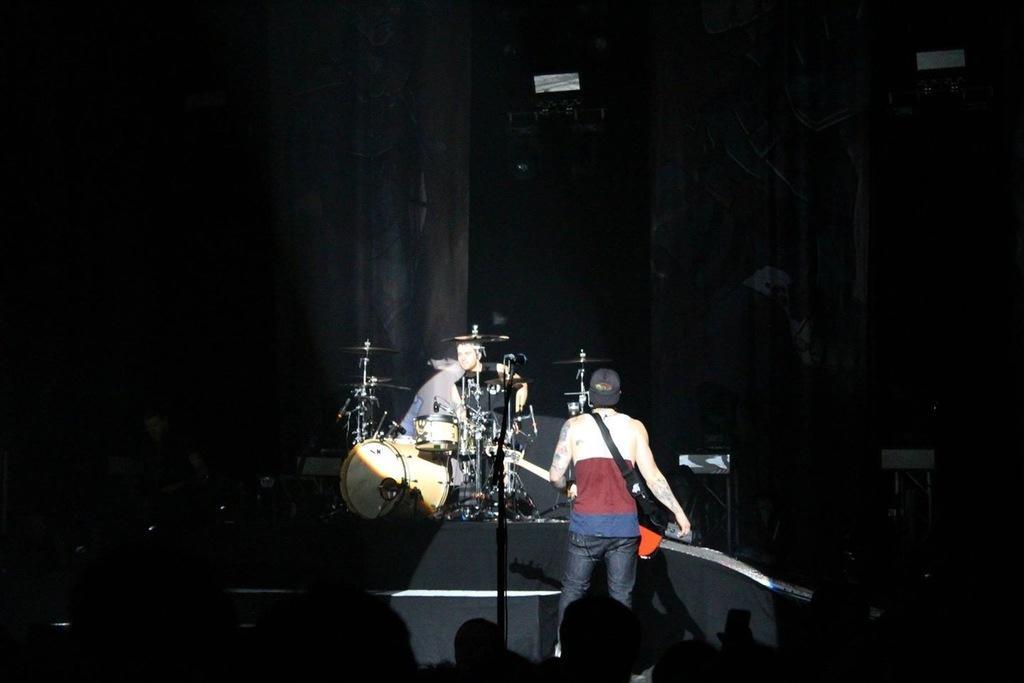Can you describe this image briefly? In this picture we can see two men on stage playing musical instruments such as guitar, drums and in front of them we can see a group of people and in background we can see curtains. 